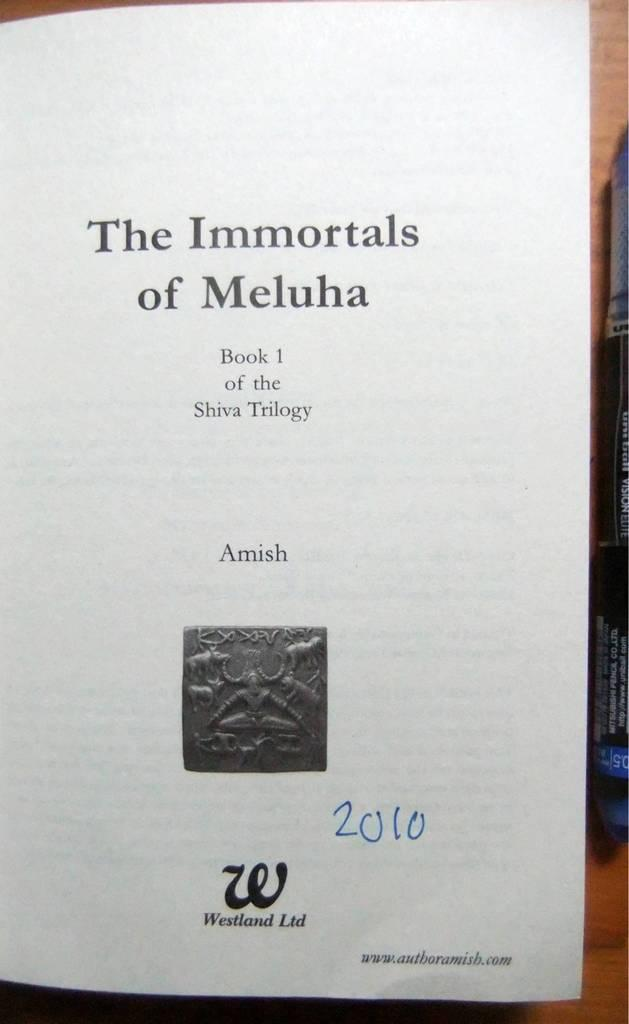<image>
Write a terse but informative summary of the picture. The first page of a book titled The Immortals of Meluha. 